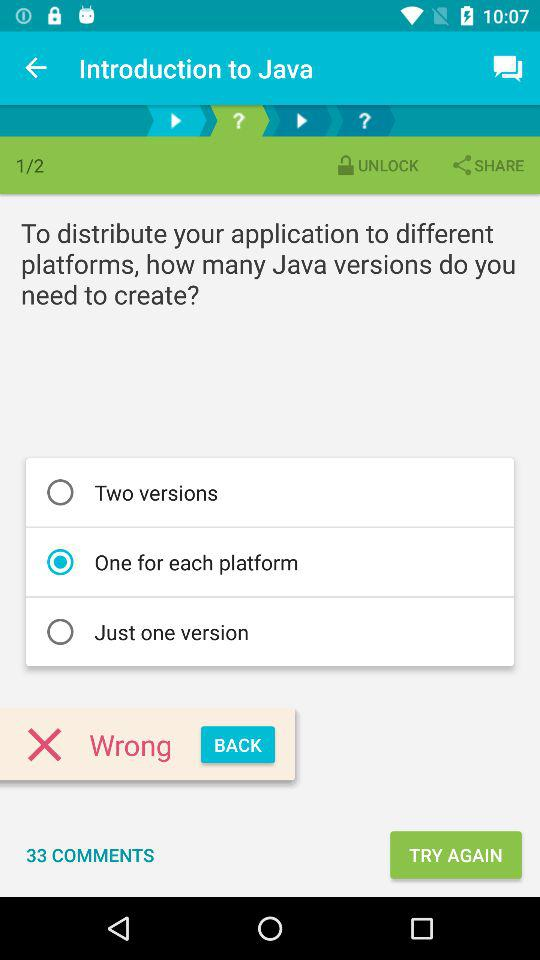How many pages in total are there? There are 2 pages. 